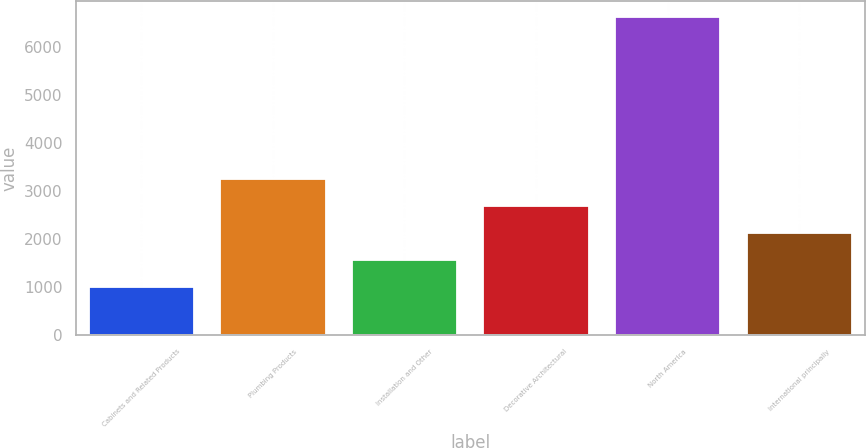Convert chart to OTSL. <chart><loc_0><loc_0><loc_500><loc_500><bar_chart><fcel>Cabinets and Related Products<fcel>Plumbing Products<fcel>Installation and Other<fcel>Decorative Architectural<fcel>North America<fcel>International principally<nl><fcel>1014<fcel>3262<fcel>1576<fcel>2700<fcel>6634<fcel>2138<nl></chart> 